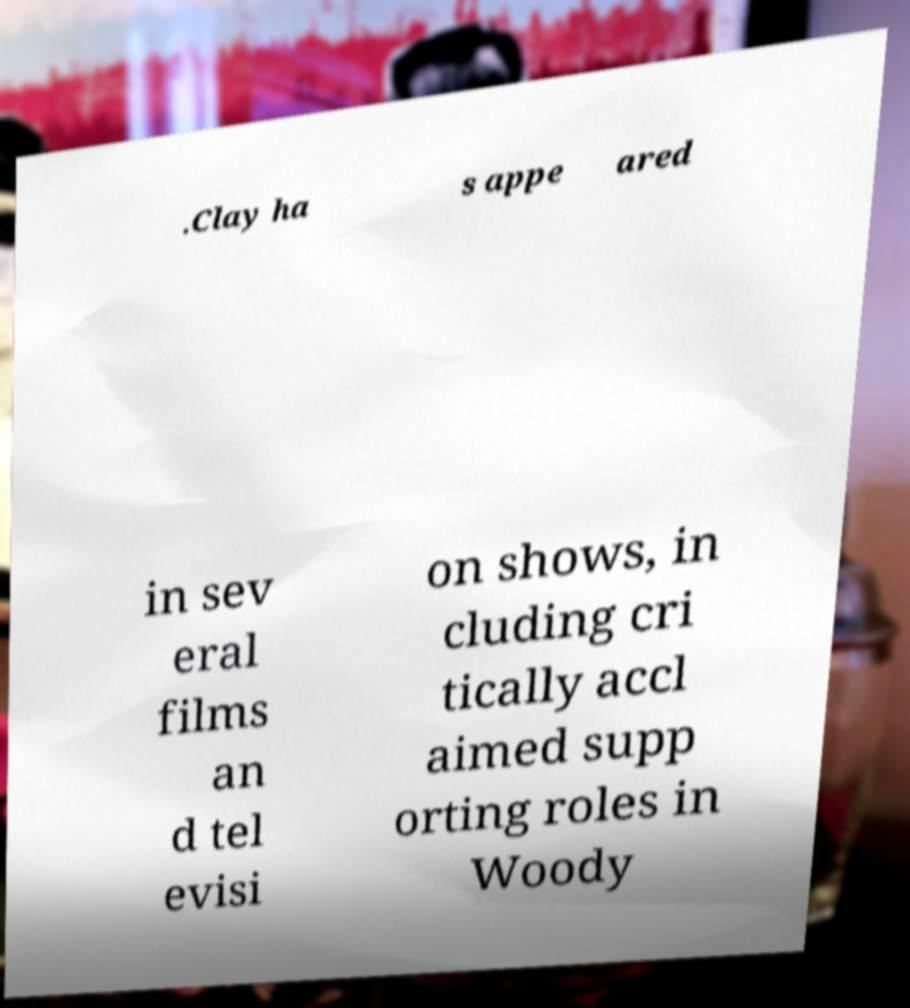Can you read and provide the text displayed in the image?This photo seems to have some interesting text. Can you extract and type it out for me? .Clay ha s appe ared in sev eral films an d tel evisi on shows, in cluding cri tically accl aimed supp orting roles in Woody 